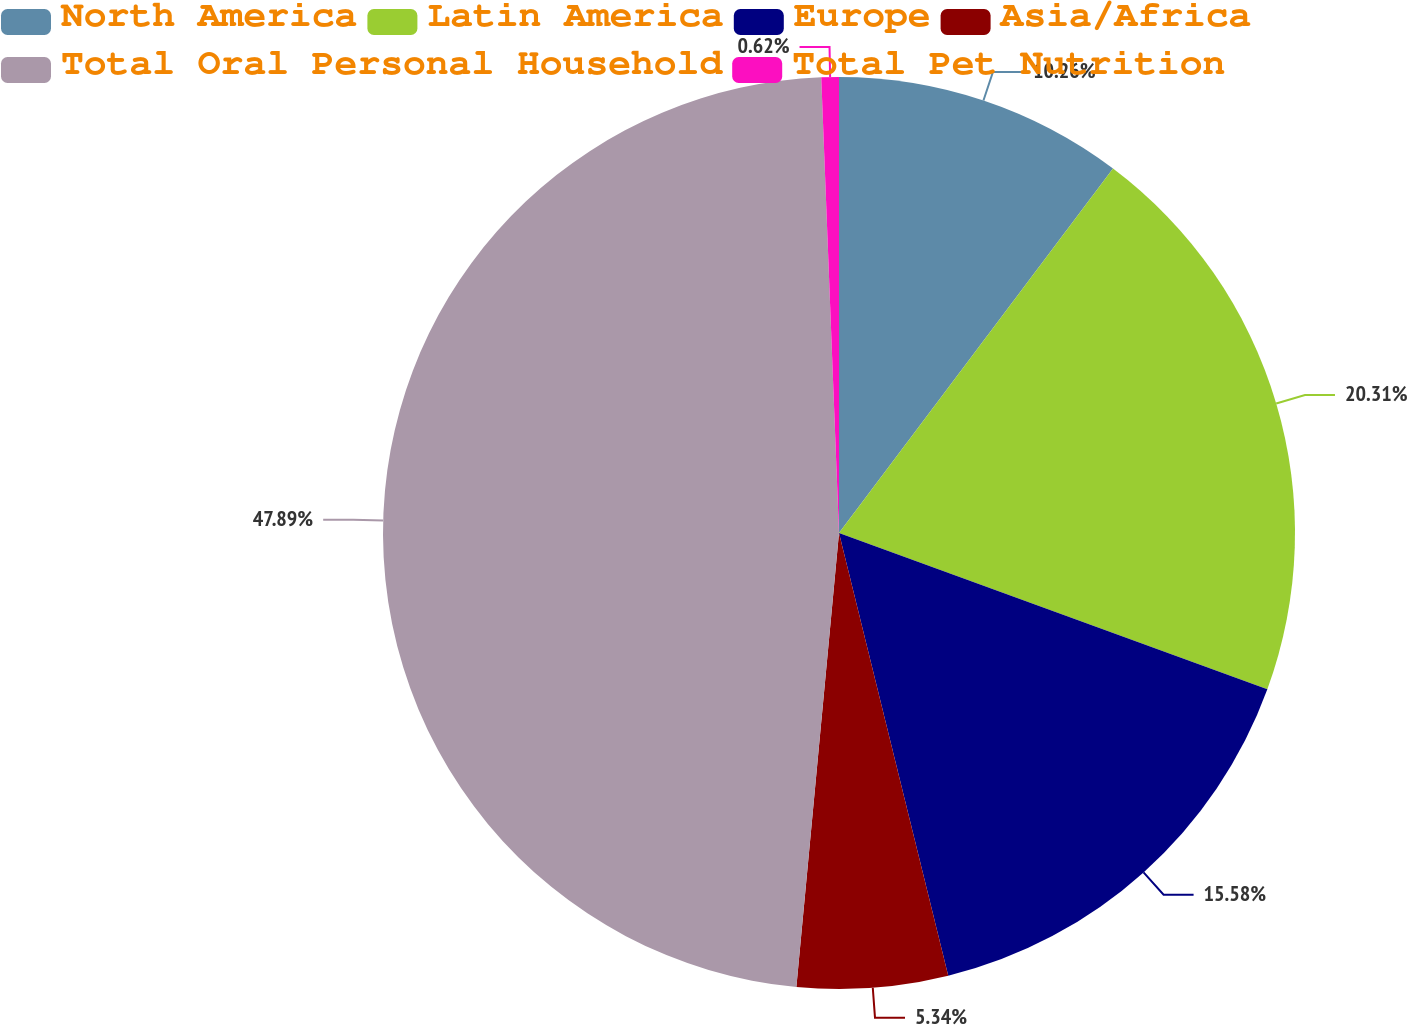Convert chart to OTSL. <chart><loc_0><loc_0><loc_500><loc_500><pie_chart><fcel>North America<fcel>Latin America<fcel>Europe<fcel>Asia/Africa<fcel>Total Oral Personal Household<fcel>Total Pet Nutrition<nl><fcel>10.26%<fcel>20.31%<fcel>15.58%<fcel>5.34%<fcel>47.89%<fcel>0.62%<nl></chart> 